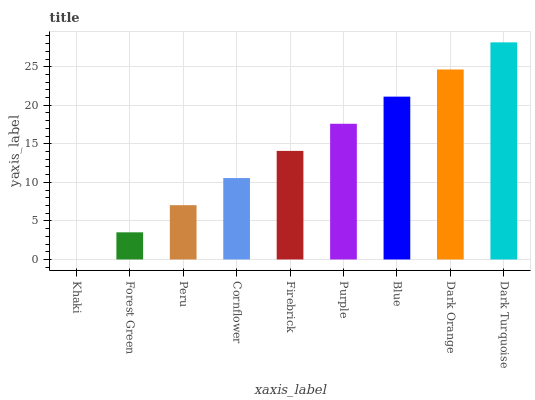Is Khaki the minimum?
Answer yes or no. Yes. Is Dark Turquoise the maximum?
Answer yes or no. Yes. Is Forest Green the minimum?
Answer yes or no. No. Is Forest Green the maximum?
Answer yes or no. No. Is Forest Green greater than Khaki?
Answer yes or no. Yes. Is Khaki less than Forest Green?
Answer yes or no. Yes. Is Khaki greater than Forest Green?
Answer yes or no. No. Is Forest Green less than Khaki?
Answer yes or no. No. Is Firebrick the high median?
Answer yes or no. Yes. Is Firebrick the low median?
Answer yes or no. Yes. Is Peru the high median?
Answer yes or no. No. Is Forest Green the low median?
Answer yes or no. No. 